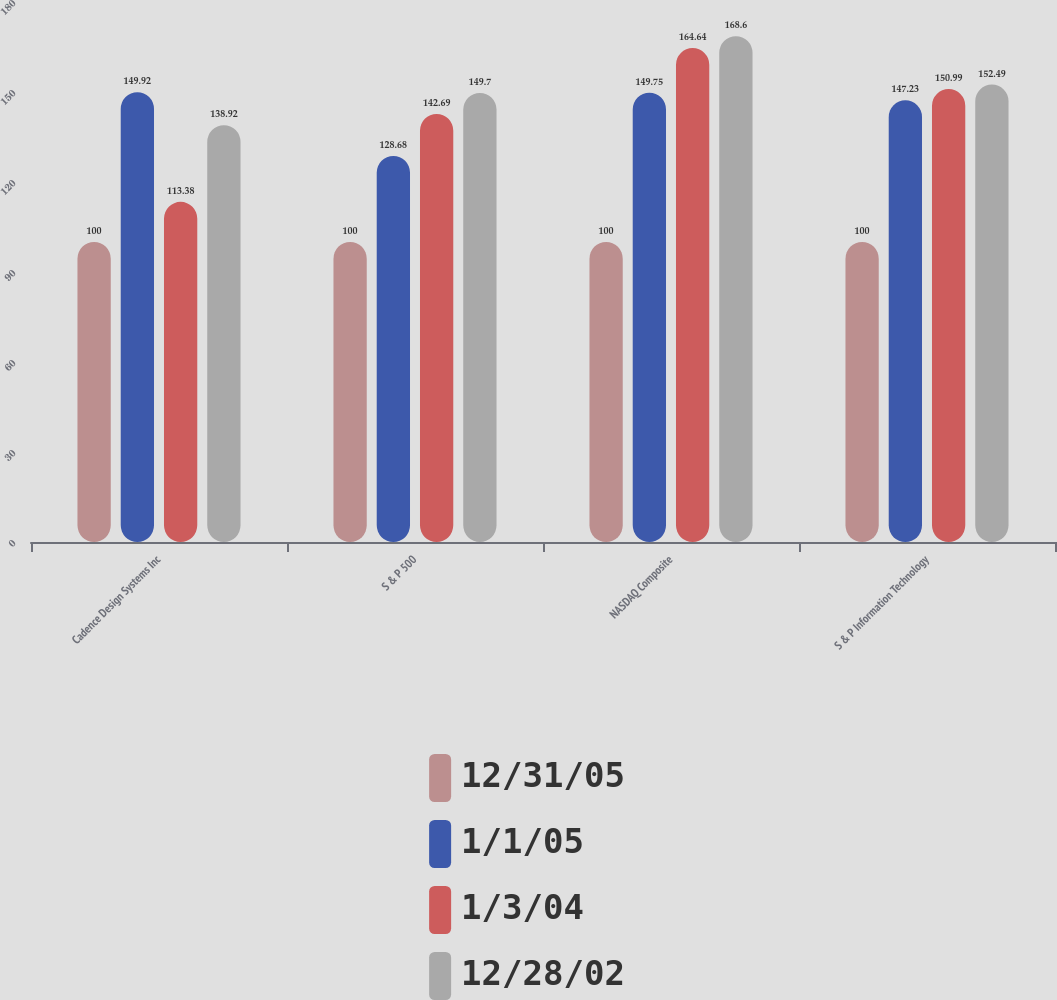Convert chart to OTSL. <chart><loc_0><loc_0><loc_500><loc_500><stacked_bar_chart><ecel><fcel>Cadence Design Systems Inc<fcel>S & P 500<fcel>NASDAQ Composite<fcel>S & P Information Technology<nl><fcel>12/31/05<fcel>100<fcel>100<fcel>100<fcel>100<nl><fcel>1/1/05<fcel>149.92<fcel>128.68<fcel>149.75<fcel>147.23<nl><fcel>1/3/04<fcel>113.38<fcel>142.69<fcel>164.64<fcel>150.99<nl><fcel>12/28/02<fcel>138.92<fcel>149.7<fcel>168.6<fcel>152.49<nl></chart> 